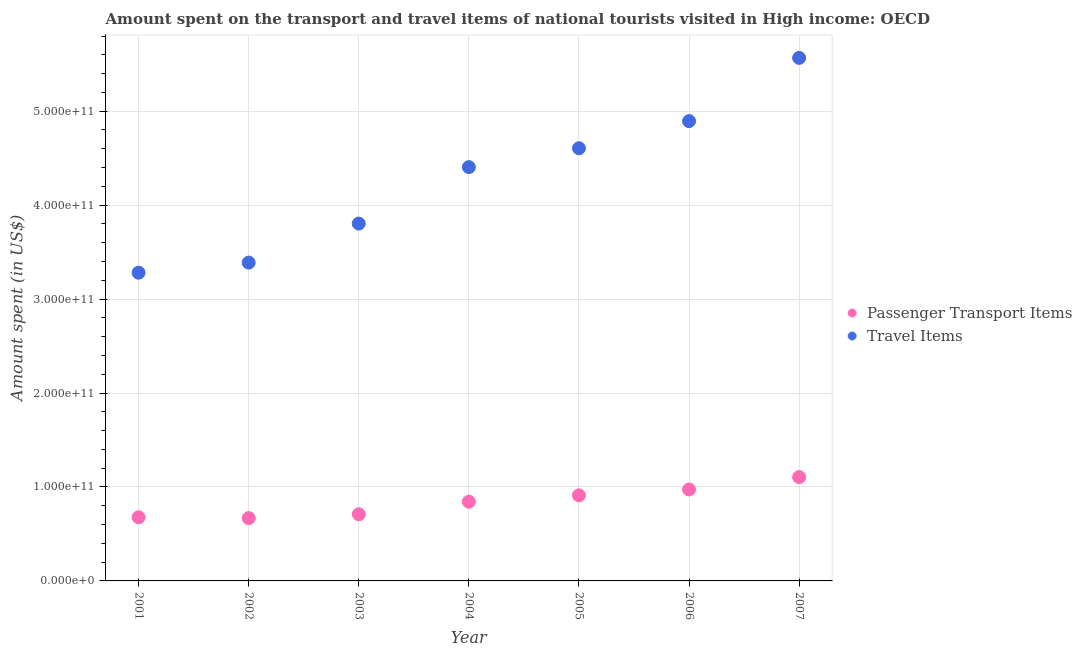What is the amount spent in travel items in 2005?
Offer a very short reply. 4.61e+11. Across all years, what is the maximum amount spent in travel items?
Offer a very short reply. 5.57e+11. Across all years, what is the minimum amount spent in travel items?
Make the answer very short. 3.28e+11. What is the total amount spent in travel items in the graph?
Your response must be concise. 2.99e+12. What is the difference between the amount spent in travel items in 2003 and that in 2005?
Ensure brevity in your answer.  -8.02e+1. What is the difference between the amount spent in travel items in 2002 and the amount spent on passenger transport items in 2004?
Your answer should be very brief. 2.54e+11. What is the average amount spent in travel items per year?
Provide a short and direct response. 4.28e+11. In the year 2005, what is the difference between the amount spent on passenger transport items and amount spent in travel items?
Your response must be concise. -3.69e+11. What is the ratio of the amount spent on passenger transport items in 2002 to that in 2005?
Your answer should be very brief. 0.73. What is the difference between the highest and the second highest amount spent in travel items?
Make the answer very short. 6.73e+1. What is the difference between the highest and the lowest amount spent on passenger transport items?
Your answer should be very brief. 4.36e+1. Is the amount spent on passenger transport items strictly less than the amount spent in travel items over the years?
Offer a terse response. Yes. What is the difference between two consecutive major ticks on the Y-axis?
Provide a succinct answer. 1.00e+11. Are the values on the major ticks of Y-axis written in scientific E-notation?
Your answer should be compact. Yes. Does the graph contain any zero values?
Your response must be concise. No. Does the graph contain grids?
Keep it short and to the point. Yes. What is the title of the graph?
Your answer should be compact. Amount spent on the transport and travel items of national tourists visited in High income: OECD. What is the label or title of the Y-axis?
Make the answer very short. Amount spent (in US$). What is the Amount spent (in US$) in Passenger Transport Items in 2001?
Provide a short and direct response. 6.78e+1. What is the Amount spent (in US$) in Travel Items in 2001?
Your answer should be compact. 3.28e+11. What is the Amount spent (in US$) in Passenger Transport Items in 2002?
Your answer should be compact. 6.69e+1. What is the Amount spent (in US$) in Travel Items in 2002?
Your answer should be very brief. 3.39e+11. What is the Amount spent (in US$) of Passenger Transport Items in 2003?
Provide a succinct answer. 7.10e+1. What is the Amount spent (in US$) in Travel Items in 2003?
Provide a succinct answer. 3.80e+11. What is the Amount spent (in US$) of Passenger Transport Items in 2004?
Offer a very short reply. 8.43e+1. What is the Amount spent (in US$) in Travel Items in 2004?
Ensure brevity in your answer.  4.40e+11. What is the Amount spent (in US$) of Passenger Transport Items in 2005?
Give a very brief answer. 9.11e+1. What is the Amount spent (in US$) in Travel Items in 2005?
Keep it short and to the point. 4.61e+11. What is the Amount spent (in US$) in Passenger Transport Items in 2006?
Offer a terse response. 9.73e+1. What is the Amount spent (in US$) in Travel Items in 2006?
Make the answer very short. 4.89e+11. What is the Amount spent (in US$) of Passenger Transport Items in 2007?
Make the answer very short. 1.11e+11. What is the Amount spent (in US$) of Travel Items in 2007?
Give a very brief answer. 5.57e+11. Across all years, what is the maximum Amount spent (in US$) in Passenger Transport Items?
Your answer should be very brief. 1.11e+11. Across all years, what is the maximum Amount spent (in US$) in Travel Items?
Your response must be concise. 5.57e+11. Across all years, what is the minimum Amount spent (in US$) in Passenger Transport Items?
Your answer should be very brief. 6.69e+1. Across all years, what is the minimum Amount spent (in US$) in Travel Items?
Your answer should be very brief. 3.28e+11. What is the total Amount spent (in US$) of Passenger Transport Items in the graph?
Keep it short and to the point. 5.89e+11. What is the total Amount spent (in US$) of Travel Items in the graph?
Offer a terse response. 2.99e+12. What is the difference between the Amount spent (in US$) of Passenger Transport Items in 2001 and that in 2002?
Your answer should be compact. 9.02e+08. What is the difference between the Amount spent (in US$) in Travel Items in 2001 and that in 2002?
Make the answer very short. -1.08e+1. What is the difference between the Amount spent (in US$) in Passenger Transport Items in 2001 and that in 2003?
Offer a very short reply. -3.21e+09. What is the difference between the Amount spent (in US$) in Travel Items in 2001 and that in 2003?
Your response must be concise. -5.23e+1. What is the difference between the Amount spent (in US$) in Passenger Transport Items in 2001 and that in 2004?
Provide a short and direct response. -1.66e+1. What is the difference between the Amount spent (in US$) of Travel Items in 2001 and that in 2004?
Keep it short and to the point. -1.12e+11. What is the difference between the Amount spent (in US$) of Passenger Transport Items in 2001 and that in 2005?
Provide a succinct answer. -2.34e+1. What is the difference between the Amount spent (in US$) of Travel Items in 2001 and that in 2005?
Offer a terse response. -1.32e+11. What is the difference between the Amount spent (in US$) in Passenger Transport Items in 2001 and that in 2006?
Offer a very short reply. -2.96e+1. What is the difference between the Amount spent (in US$) in Travel Items in 2001 and that in 2006?
Your answer should be compact. -1.61e+11. What is the difference between the Amount spent (in US$) of Passenger Transport Items in 2001 and that in 2007?
Your response must be concise. -4.27e+1. What is the difference between the Amount spent (in US$) of Travel Items in 2001 and that in 2007?
Your response must be concise. -2.29e+11. What is the difference between the Amount spent (in US$) of Passenger Transport Items in 2002 and that in 2003?
Offer a very short reply. -4.11e+09. What is the difference between the Amount spent (in US$) of Travel Items in 2002 and that in 2003?
Offer a terse response. -4.15e+1. What is the difference between the Amount spent (in US$) of Passenger Transport Items in 2002 and that in 2004?
Keep it short and to the point. -1.75e+1. What is the difference between the Amount spent (in US$) in Travel Items in 2002 and that in 2004?
Keep it short and to the point. -1.02e+11. What is the difference between the Amount spent (in US$) in Passenger Transport Items in 2002 and that in 2005?
Keep it short and to the point. -2.43e+1. What is the difference between the Amount spent (in US$) in Travel Items in 2002 and that in 2005?
Make the answer very short. -1.22e+11. What is the difference between the Amount spent (in US$) of Passenger Transport Items in 2002 and that in 2006?
Offer a very short reply. -3.05e+1. What is the difference between the Amount spent (in US$) of Travel Items in 2002 and that in 2006?
Ensure brevity in your answer.  -1.51e+11. What is the difference between the Amount spent (in US$) in Passenger Transport Items in 2002 and that in 2007?
Make the answer very short. -4.36e+1. What is the difference between the Amount spent (in US$) of Travel Items in 2002 and that in 2007?
Your response must be concise. -2.18e+11. What is the difference between the Amount spent (in US$) in Passenger Transport Items in 2003 and that in 2004?
Your answer should be very brief. -1.34e+1. What is the difference between the Amount spent (in US$) in Travel Items in 2003 and that in 2004?
Your response must be concise. -6.01e+1. What is the difference between the Amount spent (in US$) of Passenger Transport Items in 2003 and that in 2005?
Make the answer very short. -2.01e+1. What is the difference between the Amount spent (in US$) of Travel Items in 2003 and that in 2005?
Provide a succinct answer. -8.02e+1. What is the difference between the Amount spent (in US$) of Passenger Transport Items in 2003 and that in 2006?
Offer a terse response. -2.64e+1. What is the difference between the Amount spent (in US$) of Travel Items in 2003 and that in 2006?
Keep it short and to the point. -1.09e+11. What is the difference between the Amount spent (in US$) of Passenger Transport Items in 2003 and that in 2007?
Ensure brevity in your answer.  -3.95e+1. What is the difference between the Amount spent (in US$) in Travel Items in 2003 and that in 2007?
Your answer should be compact. -1.76e+11. What is the difference between the Amount spent (in US$) of Passenger Transport Items in 2004 and that in 2005?
Keep it short and to the point. -6.77e+09. What is the difference between the Amount spent (in US$) of Travel Items in 2004 and that in 2005?
Give a very brief answer. -2.01e+1. What is the difference between the Amount spent (in US$) in Passenger Transport Items in 2004 and that in 2006?
Your response must be concise. -1.30e+1. What is the difference between the Amount spent (in US$) of Travel Items in 2004 and that in 2006?
Provide a succinct answer. -4.90e+1. What is the difference between the Amount spent (in US$) of Passenger Transport Items in 2004 and that in 2007?
Provide a succinct answer. -2.62e+1. What is the difference between the Amount spent (in US$) in Travel Items in 2004 and that in 2007?
Give a very brief answer. -1.16e+11. What is the difference between the Amount spent (in US$) in Passenger Transport Items in 2005 and that in 2006?
Your answer should be compact. -6.23e+09. What is the difference between the Amount spent (in US$) in Travel Items in 2005 and that in 2006?
Make the answer very short. -2.89e+1. What is the difference between the Amount spent (in US$) of Passenger Transport Items in 2005 and that in 2007?
Make the answer very short. -1.94e+1. What is the difference between the Amount spent (in US$) in Travel Items in 2005 and that in 2007?
Your answer should be very brief. -9.62e+1. What is the difference between the Amount spent (in US$) in Passenger Transport Items in 2006 and that in 2007?
Provide a short and direct response. -1.32e+1. What is the difference between the Amount spent (in US$) in Travel Items in 2006 and that in 2007?
Your answer should be very brief. -6.73e+1. What is the difference between the Amount spent (in US$) of Passenger Transport Items in 2001 and the Amount spent (in US$) of Travel Items in 2002?
Offer a very short reply. -2.71e+11. What is the difference between the Amount spent (in US$) of Passenger Transport Items in 2001 and the Amount spent (in US$) of Travel Items in 2003?
Provide a short and direct response. -3.13e+11. What is the difference between the Amount spent (in US$) of Passenger Transport Items in 2001 and the Amount spent (in US$) of Travel Items in 2004?
Give a very brief answer. -3.73e+11. What is the difference between the Amount spent (in US$) in Passenger Transport Items in 2001 and the Amount spent (in US$) in Travel Items in 2005?
Give a very brief answer. -3.93e+11. What is the difference between the Amount spent (in US$) in Passenger Transport Items in 2001 and the Amount spent (in US$) in Travel Items in 2006?
Provide a succinct answer. -4.22e+11. What is the difference between the Amount spent (in US$) of Passenger Transport Items in 2001 and the Amount spent (in US$) of Travel Items in 2007?
Ensure brevity in your answer.  -4.89e+11. What is the difference between the Amount spent (in US$) of Passenger Transport Items in 2002 and the Amount spent (in US$) of Travel Items in 2003?
Offer a terse response. -3.13e+11. What is the difference between the Amount spent (in US$) in Passenger Transport Items in 2002 and the Amount spent (in US$) in Travel Items in 2004?
Provide a succinct answer. -3.74e+11. What is the difference between the Amount spent (in US$) in Passenger Transport Items in 2002 and the Amount spent (in US$) in Travel Items in 2005?
Provide a succinct answer. -3.94e+11. What is the difference between the Amount spent (in US$) in Passenger Transport Items in 2002 and the Amount spent (in US$) in Travel Items in 2006?
Your response must be concise. -4.23e+11. What is the difference between the Amount spent (in US$) in Passenger Transport Items in 2002 and the Amount spent (in US$) in Travel Items in 2007?
Your answer should be compact. -4.90e+11. What is the difference between the Amount spent (in US$) of Passenger Transport Items in 2003 and the Amount spent (in US$) of Travel Items in 2004?
Offer a very short reply. -3.69e+11. What is the difference between the Amount spent (in US$) of Passenger Transport Items in 2003 and the Amount spent (in US$) of Travel Items in 2005?
Ensure brevity in your answer.  -3.90e+11. What is the difference between the Amount spent (in US$) in Passenger Transport Items in 2003 and the Amount spent (in US$) in Travel Items in 2006?
Offer a terse response. -4.18e+11. What is the difference between the Amount spent (in US$) of Passenger Transport Items in 2003 and the Amount spent (in US$) of Travel Items in 2007?
Make the answer very short. -4.86e+11. What is the difference between the Amount spent (in US$) in Passenger Transport Items in 2004 and the Amount spent (in US$) in Travel Items in 2005?
Offer a very short reply. -3.76e+11. What is the difference between the Amount spent (in US$) in Passenger Transport Items in 2004 and the Amount spent (in US$) in Travel Items in 2006?
Keep it short and to the point. -4.05e+11. What is the difference between the Amount spent (in US$) in Passenger Transport Items in 2004 and the Amount spent (in US$) in Travel Items in 2007?
Provide a short and direct response. -4.72e+11. What is the difference between the Amount spent (in US$) of Passenger Transport Items in 2005 and the Amount spent (in US$) of Travel Items in 2006?
Your response must be concise. -3.98e+11. What is the difference between the Amount spent (in US$) of Passenger Transport Items in 2005 and the Amount spent (in US$) of Travel Items in 2007?
Keep it short and to the point. -4.66e+11. What is the difference between the Amount spent (in US$) in Passenger Transport Items in 2006 and the Amount spent (in US$) in Travel Items in 2007?
Make the answer very short. -4.59e+11. What is the average Amount spent (in US$) of Passenger Transport Items per year?
Your answer should be very brief. 8.41e+1. What is the average Amount spent (in US$) in Travel Items per year?
Give a very brief answer. 4.28e+11. In the year 2001, what is the difference between the Amount spent (in US$) of Passenger Transport Items and Amount spent (in US$) of Travel Items?
Your response must be concise. -2.60e+11. In the year 2002, what is the difference between the Amount spent (in US$) in Passenger Transport Items and Amount spent (in US$) in Travel Items?
Offer a terse response. -2.72e+11. In the year 2003, what is the difference between the Amount spent (in US$) of Passenger Transport Items and Amount spent (in US$) of Travel Items?
Your response must be concise. -3.09e+11. In the year 2004, what is the difference between the Amount spent (in US$) in Passenger Transport Items and Amount spent (in US$) in Travel Items?
Give a very brief answer. -3.56e+11. In the year 2005, what is the difference between the Amount spent (in US$) in Passenger Transport Items and Amount spent (in US$) in Travel Items?
Your answer should be compact. -3.69e+11. In the year 2006, what is the difference between the Amount spent (in US$) of Passenger Transport Items and Amount spent (in US$) of Travel Items?
Give a very brief answer. -3.92e+11. In the year 2007, what is the difference between the Amount spent (in US$) in Passenger Transport Items and Amount spent (in US$) in Travel Items?
Ensure brevity in your answer.  -4.46e+11. What is the ratio of the Amount spent (in US$) in Passenger Transport Items in 2001 to that in 2002?
Your answer should be very brief. 1.01. What is the ratio of the Amount spent (in US$) of Travel Items in 2001 to that in 2002?
Your answer should be very brief. 0.97. What is the ratio of the Amount spent (in US$) in Passenger Transport Items in 2001 to that in 2003?
Your answer should be compact. 0.95. What is the ratio of the Amount spent (in US$) of Travel Items in 2001 to that in 2003?
Give a very brief answer. 0.86. What is the ratio of the Amount spent (in US$) in Passenger Transport Items in 2001 to that in 2004?
Ensure brevity in your answer.  0.8. What is the ratio of the Amount spent (in US$) of Travel Items in 2001 to that in 2004?
Offer a very short reply. 0.74. What is the ratio of the Amount spent (in US$) in Passenger Transport Items in 2001 to that in 2005?
Your response must be concise. 0.74. What is the ratio of the Amount spent (in US$) in Travel Items in 2001 to that in 2005?
Keep it short and to the point. 0.71. What is the ratio of the Amount spent (in US$) of Passenger Transport Items in 2001 to that in 2006?
Keep it short and to the point. 0.7. What is the ratio of the Amount spent (in US$) of Travel Items in 2001 to that in 2006?
Keep it short and to the point. 0.67. What is the ratio of the Amount spent (in US$) in Passenger Transport Items in 2001 to that in 2007?
Offer a very short reply. 0.61. What is the ratio of the Amount spent (in US$) of Travel Items in 2001 to that in 2007?
Ensure brevity in your answer.  0.59. What is the ratio of the Amount spent (in US$) of Passenger Transport Items in 2002 to that in 2003?
Offer a very short reply. 0.94. What is the ratio of the Amount spent (in US$) of Travel Items in 2002 to that in 2003?
Provide a succinct answer. 0.89. What is the ratio of the Amount spent (in US$) of Passenger Transport Items in 2002 to that in 2004?
Make the answer very short. 0.79. What is the ratio of the Amount spent (in US$) in Travel Items in 2002 to that in 2004?
Keep it short and to the point. 0.77. What is the ratio of the Amount spent (in US$) in Passenger Transport Items in 2002 to that in 2005?
Keep it short and to the point. 0.73. What is the ratio of the Amount spent (in US$) in Travel Items in 2002 to that in 2005?
Provide a short and direct response. 0.74. What is the ratio of the Amount spent (in US$) of Passenger Transport Items in 2002 to that in 2006?
Offer a very short reply. 0.69. What is the ratio of the Amount spent (in US$) in Travel Items in 2002 to that in 2006?
Provide a succinct answer. 0.69. What is the ratio of the Amount spent (in US$) in Passenger Transport Items in 2002 to that in 2007?
Your response must be concise. 0.6. What is the ratio of the Amount spent (in US$) in Travel Items in 2002 to that in 2007?
Make the answer very short. 0.61. What is the ratio of the Amount spent (in US$) in Passenger Transport Items in 2003 to that in 2004?
Your answer should be very brief. 0.84. What is the ratio of the Amount spent (in US$) of Travel Items in 2003 to that in 2004?
Keep it short and to the point. 0.86. What is the ratio of the Amount spent (in US$) of Passenger Transport Items in 2003 to that in 2005?
Your answer should be compact. 0.78. What is the ratio of the Amount spent (in US$) in Travel Items in 2003 to that in 2005?
Provide a short and direct response. 0.83. What is the ratio of the Amount spent (in US$) of Passenger Transport Items in 2003 to that in 2006?
Your response must be concise. 0.73. What is the ratio of the Amount spent (in US$) in Travel Items in 2003 to that in 2006?
Make the answer very short. 0.78. What is the ratio of the Amount spent (in US$) of Passenger Transport Items in 2003 to that in 2007?
Keep it short and to the point. 0.64. What is the ratio of the Amount spent (in US$) of Travel Items in 2003 to that in 2007?
Keep it short and to the point. 0.68. What is the ratio of the Amount spent (in US$) of Passenger Transport Items in 2004 to that in 2005?
Keep it short and to the point. 0.93. What is the ratio of the Amount spent (in US$) of Travel Items in 2004 to that in 2005?
Offer a very short reply. 0.96. What is the ratio of the Amount spent (in US$) of Passenger Transport Items in 2004 to that in 2006?
Give a very brief answer. 0.87. What is the ratio of the Amount spent (in US$) of Travel Items in 2004 to that in 2006?
Your response must be concise. 0.9. What is the ratio of the Amount spent (in US$) in Passenger Transport Items in 2004 to that in 2007?
Your answer should be compact. 0.76. What is the ratio of the Amount spent (in US$) of Travel Items in 2004 to that in 2007?
Keep it short and to the point. 0.79. What is the ratio of the Amount spent (in US$) of Passenger Transport Items in 2005 to that in 2006?
Offer a terse response. 0.94. What is the ratio of the Amount spent (in US$) in Travel Items in 2005 to that in 2006?
Offer a terse response. 0.94. What is the ratio of the Amount spent (in US$) in Passenger Transport Items in 2005 to that in 2007?
Ensure brevity in your answer.  0.82. What is the ratio of the Amount spent (in US$) of Travel Items in 2005 to that in 2007?
Your answer should be very brief. 0.83. What is the ratio of the Amount spent (in US$) of Passenger Transport Items in 2006 to that in 2007?
Make the answer very short. 0.88. What is the ratio of the Amount spent (in US$) of Travel Items in 2006 to that in 2007?
Your answer should be compact. 0.88. What is the difference between the highest and the second highest Amount spent (in US$) of Passenger Transport Items?
Your answer should be very brief. 1.32e+1. What is the difference between the highest and the second highest Amount spent (in US$) in Travel Items?
Your response must be concise. 6.73e+1. What is the difference between the highest and the lowest Amount spent (in US$) in Passenger Transport Items?
Give a very brief answer. 4.36e+1. What is the difference between the highest and the lowest Amount spent (in US$) of Travel Items?
Ensure brevity in your answer.  2.29e+11. 